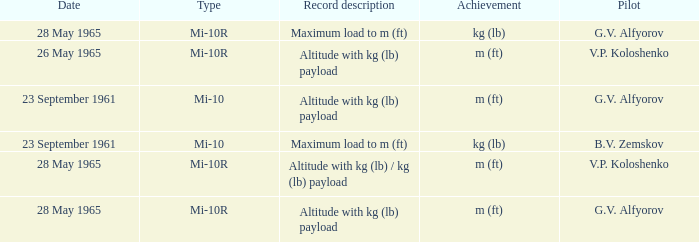Type of mi-10r, and a Record description of altitude with kg (lb) payload, and a Pilot of g.v. alfyorov is what date? 28 May 1965. 